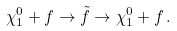<formula> <loc_0><loc_0><loc_500><loc_500>\chi _ { 1 } ^ { 0 } + f \rightarrow { \tilde { f } } \rightarrow \chi _ { 1 } ^ { 0 } + f \, .</formula> 